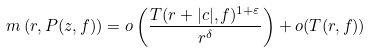Convert formula to latex. <formula><loc_0><loc_0><loc_500><loc_500>m \left ( r , P ( z , f ) \right ) = o \left ( \frac { T ( r + | c | , f ) ^ { 1 + \varepsilon } } { r ^ { \delta } } \right ) + o ( T ( r , f ) )</formula> 